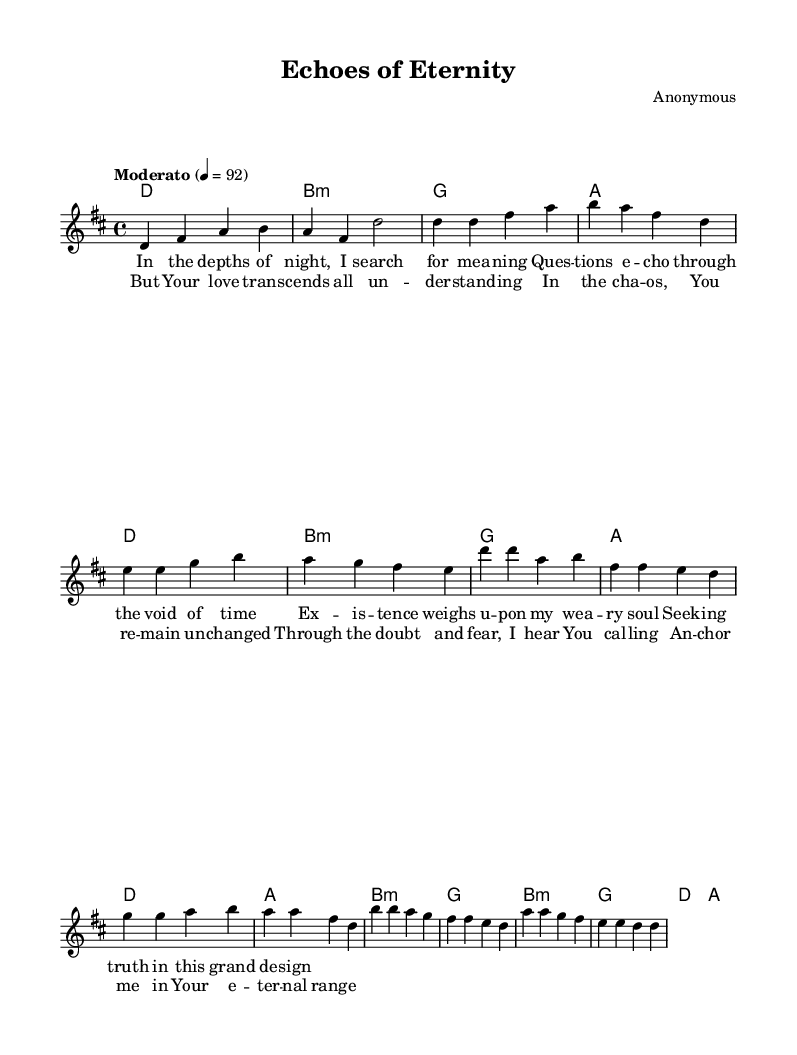What is the key signature of this music? The key signature is indicated at the beginning of the music, denoting D major, which has two sharps (F# and C#) in its scale.
Answer: D major What is the time signature of this music? The time signature is shown at the beginning of the sheet music, displaying a 4/4 time signature, which indicates four beats per measure and a quarter note gets one beat.
Answer: 4/4 What is the tempo marking for this piece? The tempo marking is noted in the score with "Moderato" and a metronome marking of 92, indicating a moderate pace.
Answer: Moderato How many verses are present in the song? By analyzing the structure of the sheet music, there is one verse presented, which is followed by a chorus.
Answer: One What chord is played during the intro? The first chord listed in the harmonies section during the intro is D major, which is explicitly labeled first in the chord progression.
Answer: D What are the main themes expressed in the lyrics? The lyrics focus on existential questioning and reassurance of divine love, as seen in reflections on meaning and seeking truth.
Answer: Existential themes Which musical section contains the repeated motifs in the lyrics? The repeated motifs are located in the chorus section, which reinforces the theme of divine love and assurance in the face of chaos.
Answer: Chorus 